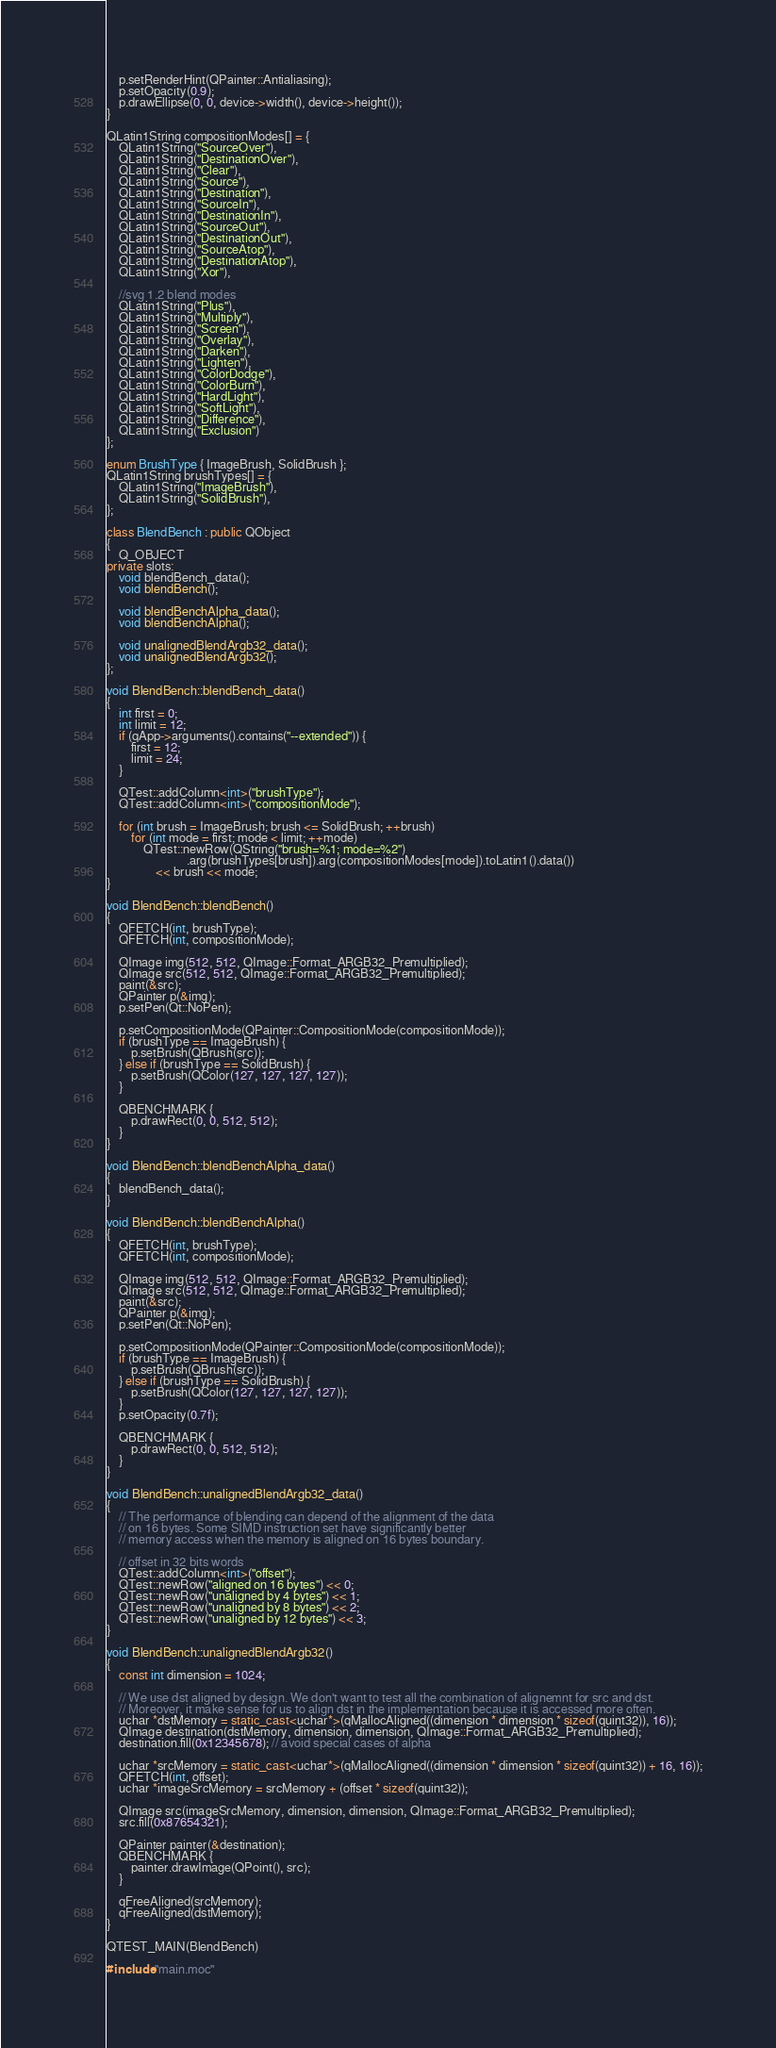Convert code to text. <code><loc_0><loc_0><loc_500><loc_500><_C++_>    p.setRenderHint(QPainter::Antialiasing);
    p.setOpacity(0.9);
    p.drawEllipse(0, 0, device->width(), device->height());
}

QLatin1String compositionModes[] = {
    QLatin1String("SourceOver"),
    QLatin1String("DestinationOver"),
    QLatin1String("Clear"),
    QLatin1String("Source"),
    QLatin1String("Destination"),
    QLatin1String("SourceIn"),
    QLatin1String("DestinationIn"),
    QLatin1String("SourceOut"),
    QLatin1String("DestinationOut"),
    QLatin1String("SourceAtop"),
    QLatin1String("DestinationAtop"),
    QLatin1String("Xor"),

    //svg 1.2 blend modes
    QLatin1String("Plus"),
    QLatin1String("Multiply"),
    QLatin1String("Screen"),
    QLatin1String("Overlay"),
    QLatin1String("Darken"),
    QLatin1String("Lighten"),
    QLatin1String("ColorDodge"),
    QLatin1String("ColorBurn"),
    QLatin1String("HardLight"),
    QLatin1String("SoftLight"),
    QLatin1String("Difference"),
    QLatin1String("Exclusion")
};

enum BrushType { ImageBrush, SolidBrush };
QLatin1String brushTypes[] = {
    QLatin1String("ImageBrush"),
    QLatin1String("SolidBrush"),
};

class BlendBench : public QObject
{
    Q_OBJECT
private slots:
    void blendBench_data();
    void blendBench();

    void blendBenchAlpha_data();
    void blendBenchAlpha();

    void unalignedBlendArgb32_data();
    void unalignedBlendArgb32();
};

void BlendBench::blendBench_data()
{
    int first = 0;
    int limit = 12;
    if (qApp->arguments().contains("--extended")) {
        first = 12;
        limit = 24;
    }

    QTest::addColumn<int>("brushType");
    QTest::addColumn<int>("compositionMode");

    for (int brush = ImageBrush; brush <= SolidBrush; ++brush)
        for (int mode = first; mode < limit; ++mode)
            QTest::newRow(QString("brush=%1; mode=%2")
                          .arg(brushTypes[brush]).arg(compositionModes[mode]).toLatin1().data())
                << brush << mode;
}

void BlendBench::blendBench()
{
    QFETCH(int, brushType);
    QFETCH(int, compositionMode);

    QImage img(512, 512, QImage::Format_ARGB32_Premultiplied);
    QImage src(512, 512, QImage::Format_ARGB32_Premultiplied);
    paint(&src);
    QPainter p(&img);
    p.setPen(Qt::NoPen);

    p.setCompositionMode(QPainter::CompositionMode(compositionMode));
    if (brushType == ImageBrush) {
        p.setBrush(QBrush(src));
    } else if (brushType == SolidBrush) {
        p.setBrush(QColor(127, 127, 127, 127));
    }

    QBENCHMARK {
        p.drawRect(0, 0, 512, 512);
    }
}

void BlendBench::blendBenchAlpha_data()
{
    blendBench_data();
}

void BlendBench::blendBenchAlpha()
{
    QFETCH(int, brushType);
    QFETCH(int, compositionMode);

    QImage img(512, 512, QImage::Format_ARGB32_Premultiplied);
    QImage src(512, 512, QImage::Format_ARGB32_Premultiplied);
    paint(&src);
    QPainter p(&img);
    p.setPen(Qt::NoPen);

    p.setCompositionMode(QPainter::CompositionMode(compositionMode));
    if (brushType == ImageBrush) {
        p.setBrush(QBrush(src));
    } else if (brushType == SolidBrush) {
        p.setBrush(QColor(127, 127, 127, 127));
    }
    p.setOpacity(0.7f);

    QBENCHMARK {
        p.drawRect(0, 0, 512, 512);
    }
}

void BlendBench::unalignedBlendArgb32_data()
{
    // The performance of blending can depend of the alignment of the data
    // on 16 bytes. Some SIMD instruction set have significantly better
    // memory access when the memory is aligned on 16 bytes boundary.

    // offset in 32 bits words
    QTest::addColumn<int>("offset");
    QTest::newRow("aligned on 16 bytes") << 0;
    QTest::newRow("unaligned by 4 bytes") << 1;
    QTest::newRow("unaligned by 8 bytes") << 2;
    QTest::newRow("unaligned by 12 bytes") << 3;
}

void BlendBench::unalignedBlendArgb32()
{
    const int dimension = 1024;

    // We use dst aligned by design. We don't want to test all the combination of alignemnt for src and dst.
    // Moreover, it make sense for us to align dst in the implementation because it is accessed more often.
    uchar *dstMemory = static_cast<uchar*>(qMallocAligned((dimension * dimension * sizeof(quint32)), 16));
    QImage destination(dstMemory, dimension, dimension, QImage::Format_ARGB32_Premultiplied);
    destination.fill(0x12345678); // avoid special cases of alpha

    uchar *srcMemory = static_cast<uchar*>(qMallocAligned((dimension * dimension * sizeof(quint32)) + 16, 16));
    QFETCH(int, offset);
    uchar *imageSrcMemory = srcMemory + (offset * sizeof(quint32));

    QImage src(imageSrcMemory, dimension, dimension, QImage::Format_ARGB32_Premultiplied);
    src.fill(0x87654321);

    QPainter painter(&destination);
    QBENCHMARK {
        painter.drawImage(QPoint(), src);
    }

    qFreeAligned(srcMemory);
    qFreeAligned(dstMemory);
}

QTEST_MAIN(BlendBench)

#include "main.moc"
</code> 